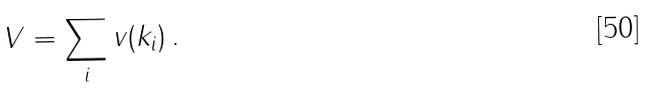<formula> <loc_0><loc_0><loc_500><loc_500>V = \sum _ { i } v ( k _ { i } ) \, .</formula> 